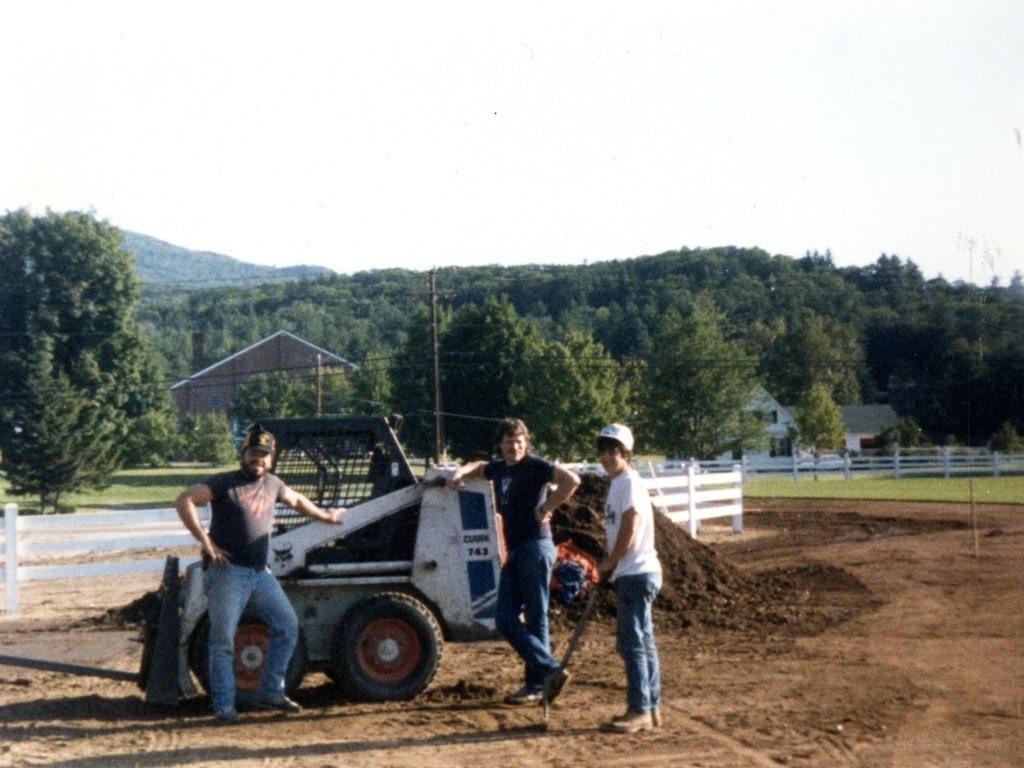How would you describe the main characters and events in the scene? The image effectively captures a moment of camaraderie and work among three individuals. They appear to be taking a break from some manual labor, as suggested by the dirt and the solid build of their bodies, which indicate physical strength likely gained from regular physical work. They are standing with a skid steer loader, which points to the nature of their activity; possibly it's related to construction or landscaping. The background features a rural setting with a picturesque view of mountains and a clear sky, implying it may be a day well-spent working outdoors. 